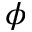Convert formula to latex. <formula><loc_0><loc_0><loc_500><loc_500>\phi</formula> 